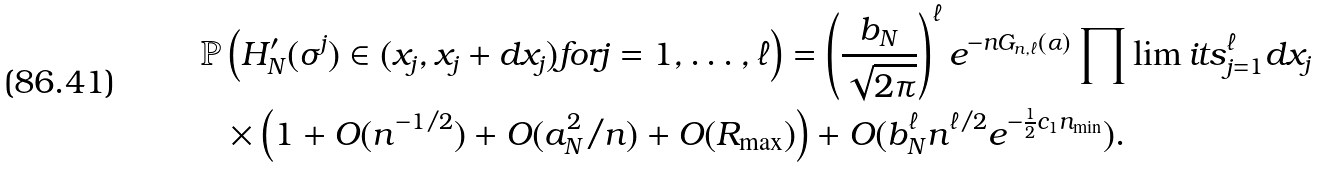Convert formula to latex. <formula><loc_0><loc_0><loc_500><loc_500>\mathbb { P } & \left ( H ^ { \prime } _ { N } ( \sigma ^ { j } ) \in ( x _ { j } , x _ { j } + d x _ { j } ) f o r j = 1 , \dots , \ell \right ) = \left ( \frac { b _ { N } } { \sqrt { 2 \pi } } \right ) ^ { \ell } e ^ { - n G _ { n , \ell } ( \boldsymbol \alpha ) } \prod \lim i t s _ { j = 1 } ^ { \ell } d x _ { j } \\ & \times \left ( 1 + O ( n ^ { - 1 / 2 } ) + O ( a _ { N } ^ { 2 } / n ) + O ( R _ { \max } ) \right ) + O ( b _ { N } ^ { \ell } n ^ { \ell / 2 } e ^ { - \frac { 1 } { 2 } c _ { 1 } n _ { \min } } ) .</formula> 